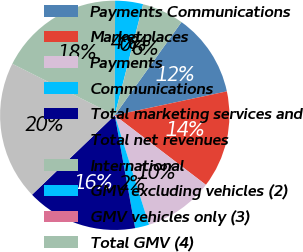Convert chart to OTSL. <chart><loc_0><loc_0><loc_500><loc_500><pie_chart><fcel>Payments Communications<fcel>Marketplaces<fcel>Payments<fcel>Communications<fcel>Total marketing services and<fcel>Total net revenues<fcel>International<fcel>GMV excluding vehicles (2)<fcel>GMV vehicles only (3)<fcel>Total GMV (4)<nl><fcel>11.76%<fcel>13.72%<fcel>9.8%<fcel>1.98%<fcel>15.67%<fcel>19.59%<fcel>17.63%<fcel>3.93%<fcel>0.02%<fcel>5.89%<nl></chart> 